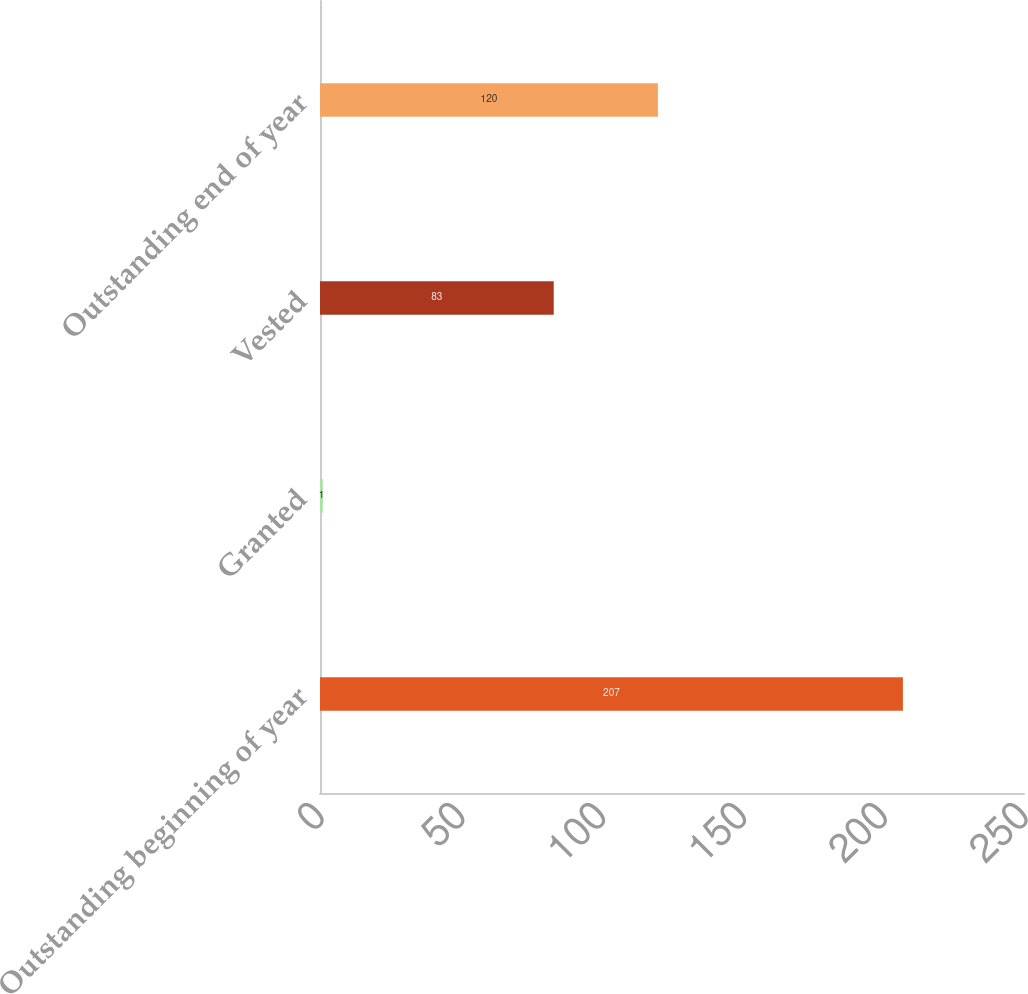Convert chart. <chart><loc_0><loc_0><loc_500><loc_500><bar_chart><fcel>Outstanding beginning of year<fcel>Granted<fcel>Vested<fcel>Outstanding end of year<nl><fcel>207<fcel>1<fcel>83<fcel>120<nl></chart> 